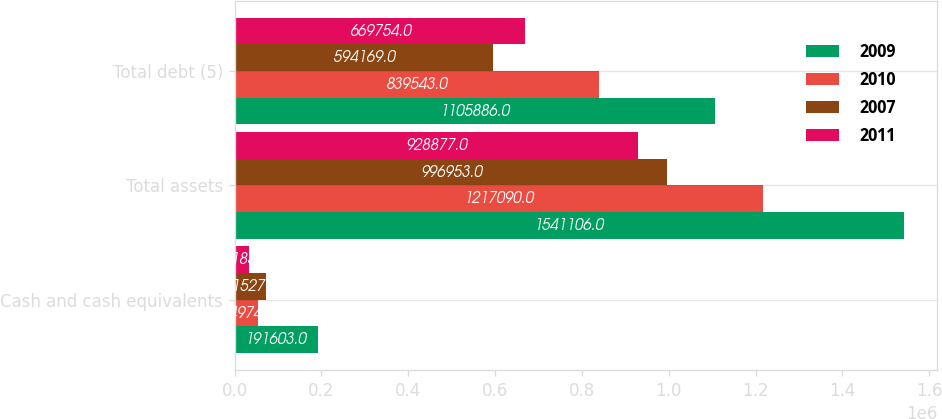Convert chart. <chart><loc_0><loc_0><loc_500><loc_500><stacked_bar_chart><ecel><fcel>Cash and cash equivalents<fcel>Total assets<fcel>Total debt (5)<nl><fcel>2009<fcel>191603<fcel>1.54111e+06<fcel>1.10589e+06<nl><fcel>2010<fcel>54974<fcel>1.21709e+06<fcel>839543<nl><fcel>2007<fcel>71527<fcel>996953<fcel>594169<nl><fcel>2011<fcel>33185<fcel>928877<fcel>669754<nl></chart> 